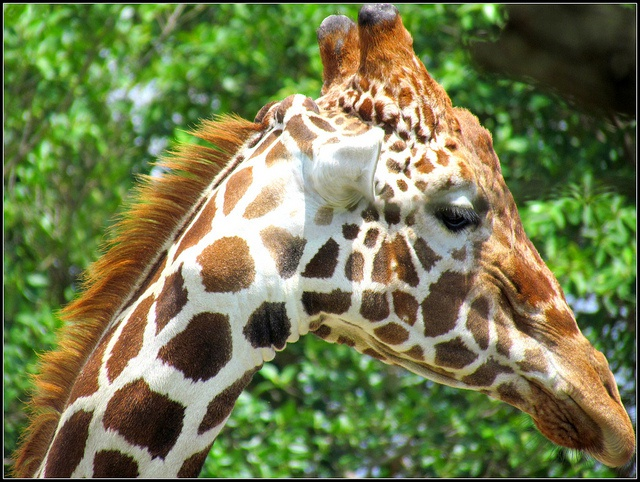Describe the objects in this image and their specific colors. I can see a giraffe in black, white, darkgray, and olive tones in this image. 